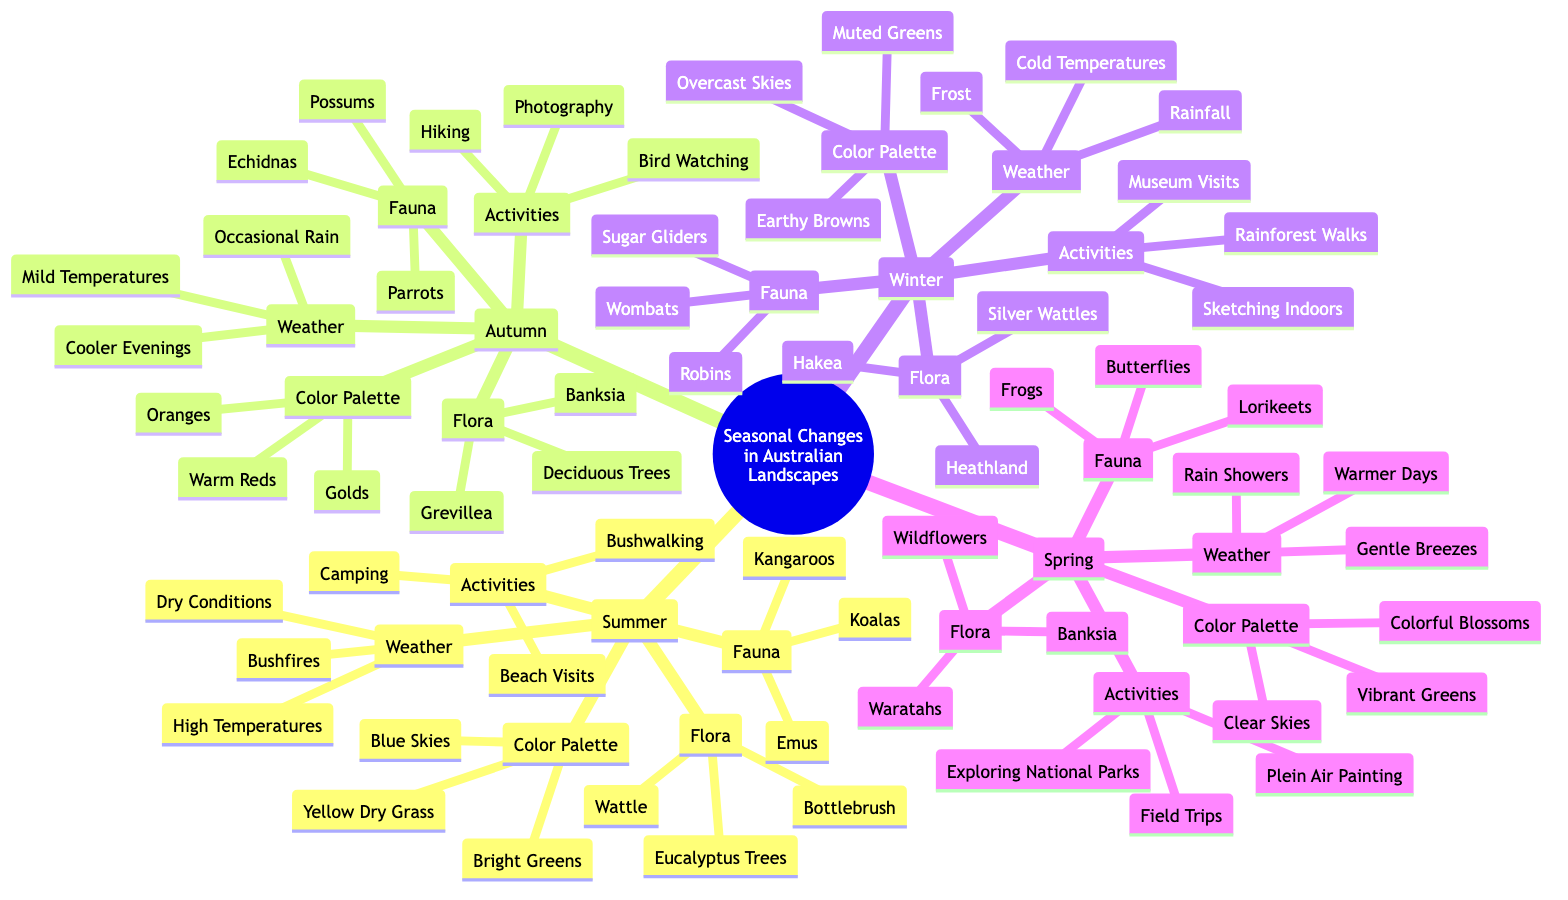What flora is associated with Summer? In the Summer section of the mind map, the flora listed includes Eucalyptus Trees, Bottlebrush, and Wattle. These are the specific plants that are characteristic of the Australian landscape during the summer season.
Answer: Eucalyptus Trees, Bottlebrush, Wattle How many fauna are listed for Autumn? The Autumn section has three fauna listed: Echidnas, Possums, and Parrots. To find this number, we simply count the items in the fauna list.
Answer: 3 What activities can be done during Winter? In the Winter section, the activities mentioned are Sketching Indoors, Museum Visits, and Rainforest Walks. These activities are suited for the colder and rainy conditions during winter.
Answer: Sketching Indoors, Museum Visits, Rainforest Walks What color palette is associated with Spring? The Spring section of the mind map features a color palette of Vibrant Greens, Colorful Blossoms, and Clear Skies. This palette reflects the vibrant and colorful aspects of the spring season in Australian landscapes.
Answer: Vibrant Greens, Colorful Blossoms, Clear Skies Which season has the weather condition "High Temperatures"? By examining the weather conditions listed in the Summer section, "High Temperatures" is mentioned as one of the key characteristics of summer, denoting its hot climatic conditions.
Answer: Summer Compare the fauna of Summer and Winter. In the Summer section, the fauna includes Kangaroos, Koalas, and Emus. In contrast, the Winter section lists Wombats, Sugar Gliders, and Robins. Each season features different animals that thrive in their respective climates, highlighting a distinct seasonal difference in fauna.
Answer: Kangaroos, Koalas, Emus; Wombats, Sugar Gliders, Robins What is one activity that can be done during Autumn? Referring to the Autumn section, one of the activities listed is Hiking. This suggests that Autumn provides a favorable climate for outdoor activities like hiking.
Answer: Hiking What is the primary weather condition in Winter? The Winter section emphasizes "Cold Temperatures" as the primary weather condition, which is a significant characteristic of the winter season in Australian landscapes.
Answer: Cold Temperatures 